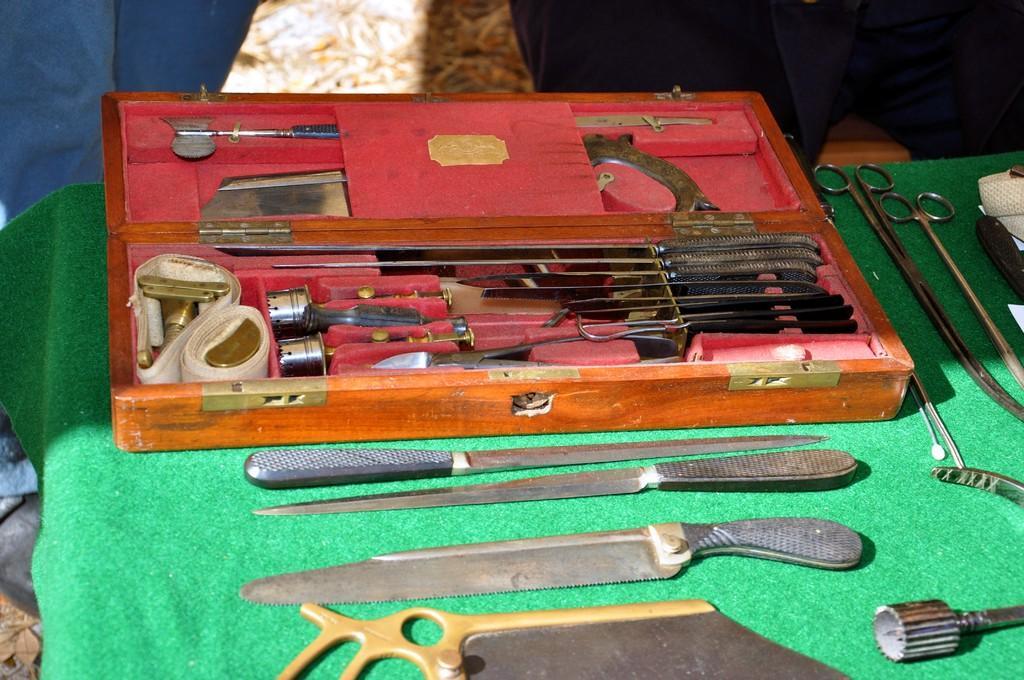Please provide a concise description of this image. In the center of the image a table is there. On the table we can see cloth, box, knife, scissors and some objects are present. 